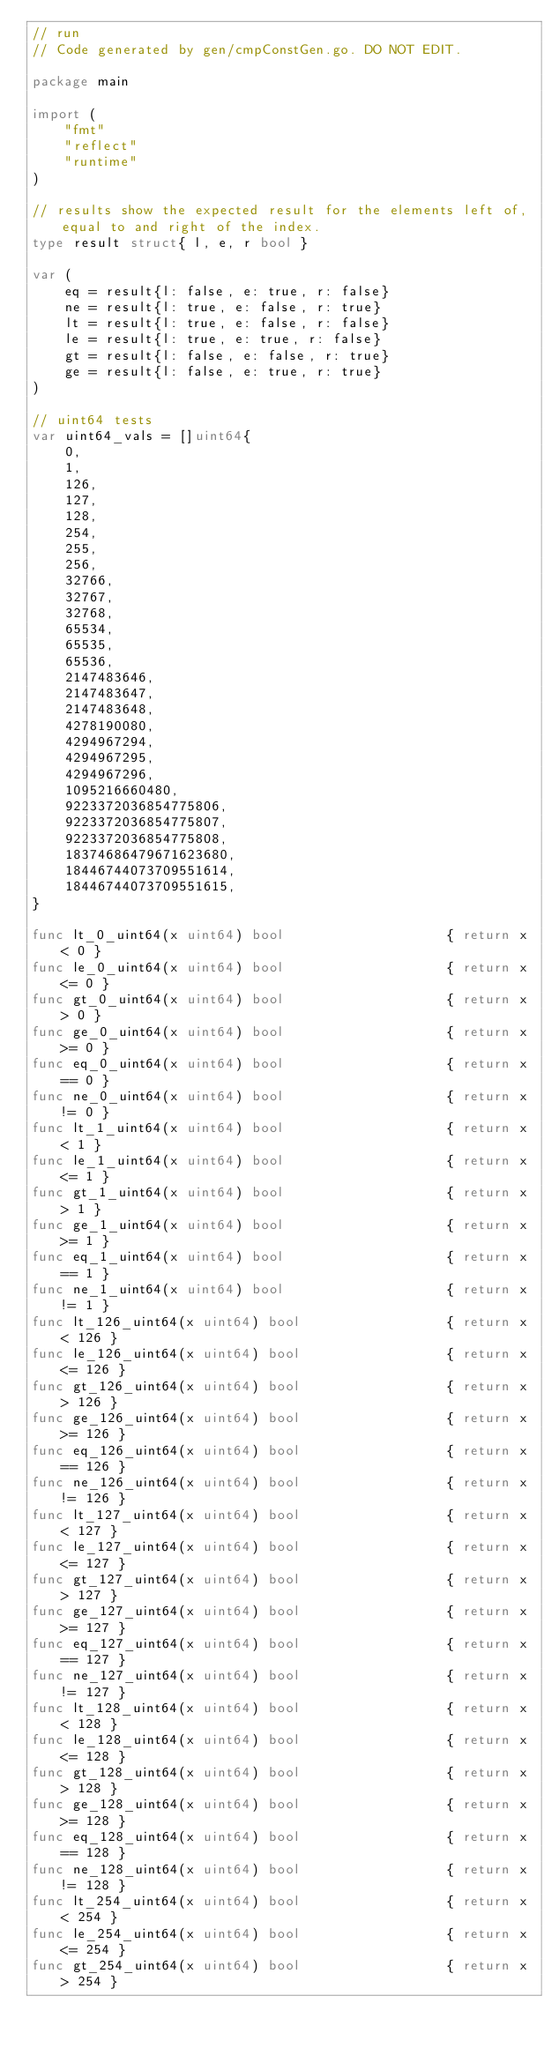<code> <loc_0><loc_0><loc_500><loc_500><_Go_>// run
// Code generated by gen/cmpConstGen.go. DO NOT EDIT.

package main

import (
	"fmt"
	"reflect"
	"runtime"
)

// results show the expected result for the elements left of, equal to and right of the index.
type result struct{ l, e, r bool }

var (
	eq = result{l: false, e: true, r: false}
	ne = result{l: true, e: false, r: true}
	lt = result{l: true, e: false, r: false}
	le = result{l: true, e: true, r: false}
	gt = result{l: false, e: false, r: true}
	ge = result{l: false, e: true, r: true}
)

// uint64 tests
var uint64_vals = []uint64{
	0,
	1,
	126,
	127,
	128,
	254,
	255,
	256,
	32766,
	32767,
	32768,
	65534,
	65535,
	65536,
	2147483646,
	2147483647,
	2147483648,
	4278190080,
	4294967294,
	4294967295,
	4294967296,
	1095216660480,
	9223372036854775806,
	9223372036854775807,
	9223372036854775808,
	18374686479671623680,
	18446744073709551614,
	18446744073709551615,
}

func lt_0_uint64(x uint64) bool                    { return x < 0 }
func le_0_uint64(x uint64) bool                    { return x <= 0 }
func gt_0_uint64(x uint64) bool                    { return x > 0 }
func ge_0_uint64(x uint64) bool                    { return x >= 0 }
func eq_0_uint64(x uint64) bool                    { return x == 0 }
func ne_0_uint64(x uint64) bool                    { return x != 0 }
func lt_1_uint64(x uint64) bool                    { return x < 1 }
func le_1_uint64(x uint64) bool                    { return x <= 1 }
func gt_1_uint64(x uint64) bool                    { return x > 1 }
func ge_1_uint64(x uint64) bool                    { return x >= 1 }
func eq_1_uint64(x uint64) bool                    { return x == 1 }
func ne_1_uint64(x uint64) bool                    { return x != 1 }
func lt_126_uint64(x uint64) bool                  { return x < 126 }
func le_126_uint64(x uint64) bool                  { return x <= 126 }
func gt_126_uint64(x uint64) bool                  { return x > 126 }
func ge_126_uint64(x uint64) bool                  { return x >= 126 }
func eq_126_uint64(x uint64) bool                  { return x == 126 }
func ne_126_uint64(x uint64) bool                  { return x != 126 }
func lt_127_uint64(x uint64) bool                  { return x < 127 }
func le_127_uint64(x uint64) bool                  { return x <= 127 }
func gt_127_uint64(x uint64) bool                  { return x > 127 }
func ge_127_uint64(x uint64) bool                  { return x >= 127 }
func eq_127_uint64(x uint64) bool                  { return x == 127 }
func ne_127_uint64(x uint64) bool                  { return x != 127 }
func lt_128_uint64(x uint64) bool                  { return x < 128 }
func le_128_uint64(x uint64) bool                  { return x <= 128 }
func gt_128_uint64(x uint64) bool                  { return x > 128 }
func ge_128_uint64(x uint64) bool                  { return x >= 128 }
func eq_128_uint64(x uint64) bool                  { return x == 128 }
func ne_128_uint64(x uint64) bool                  { return x != 128 }
func lt_254_uint64(x uint64) bool                  { return x < 254 }
func le_254_uint64(x uint64) bool                  { return x <= 254 }
func gt_254_uint64(x uint64) bool                  { return x > 254 }</code> 